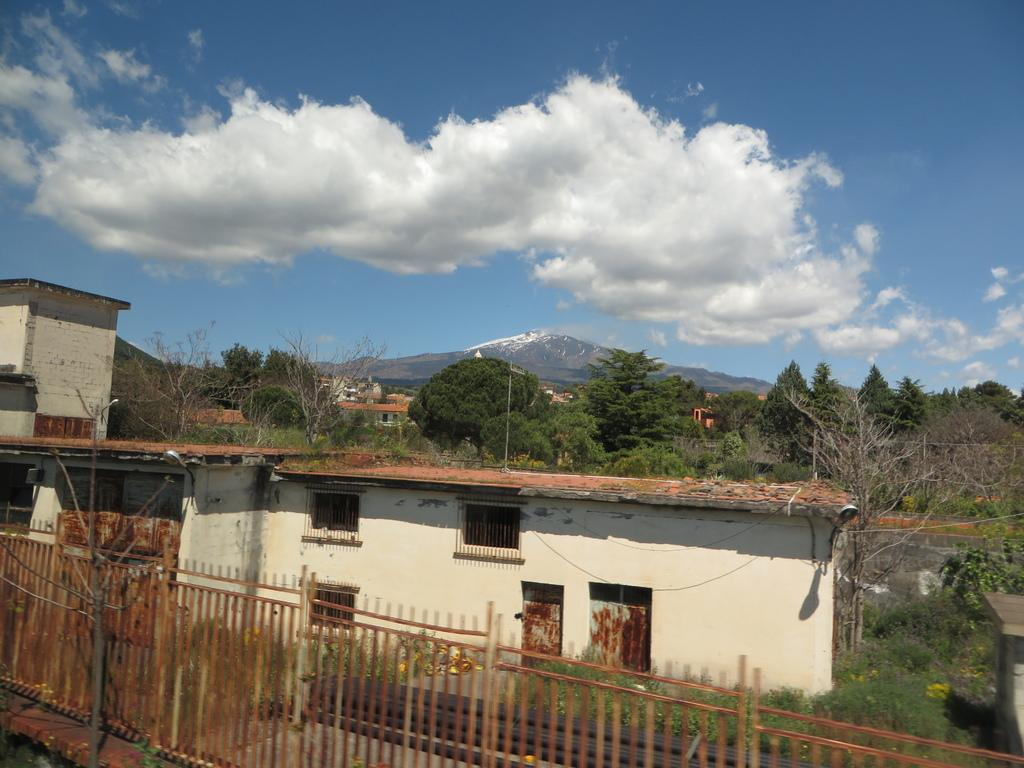What types of natural elements can be seen in the foreground of the picture? There are trees and plants in the foreground of the picture. What types of man-made structures can be seen in the foreground of the picture? There are buildings in the foreground of the picture. What feature is present in the foreground of the picture that might be used for safety or support? There is a railing in the foreground of the picture. What types of natural elements can be seen in the middle of the picture? There are trees and a mountain in the middle of the picture. What types of man-made structures can be seen in the middle of the picture? There are buildings in the middle of the picture. What part of the natural environment is visible at the top of the picture? The sky is visible at the top of the picture. Where is the bee located in the picture, and what type of jam is it flying towards? There is no bee or jam present in the picture. What type of club can be seen in the picture, and who is using it? There is no club present in the picture. 